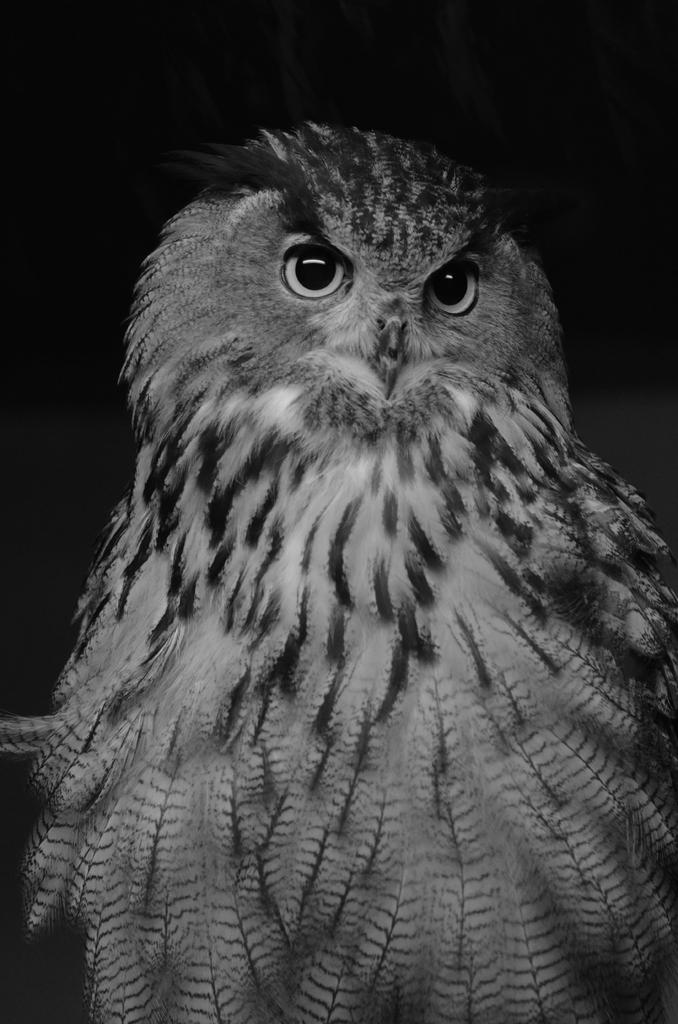What is the color scheme of the picture? The picture is black and white. What animal can be seen in the picture? There is an owl in the picture. What type of breakfast is the owl eating in the picture? There is no breakfast present in the picture, as it is a black and white image of an owl. What reward can be seen in the cave behind the owl? There is no cave or reward present in the picture; it only features an owl in a black and white setting. 